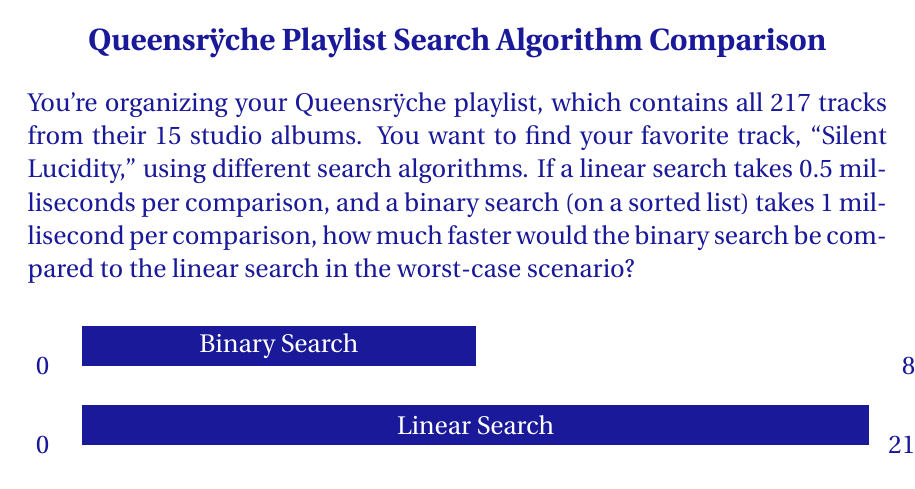Could you help me with this problem? Let's approach this step-by-step:

1) For linear search:
   - Worst case: The item is at the end or not in the list
   - Number of comparisons: 217
   - Time per comparison: 0.5 ms
   - Total time: $217 * 0.5 = 108.5$ ms

2) For binary search:
   - Worst case: The item is not in the list or is found in the last comparison
   - Number of comparisons: $\lceil \log_2(217) \rceil = 8$
     (We use the ceiling function because we need a whole number of comparisons)
   - Time per comparison: 1 ms
   - Total time: $8 * 1 = 8$ ms

3) To find how much faster binary search is:
   $\text{Speed-up factor} = \frac{\text{Linear search time}}{\text{Binary search time}}$
   
   $$ \text{Speed-up factor} = \frac{108.5}{8} = 13.5625 $$

Therefore, the binary search would be approximately 13.5625 times faster than the linear search in the worst-case scenario.
Answer: 13.5625 times faster 